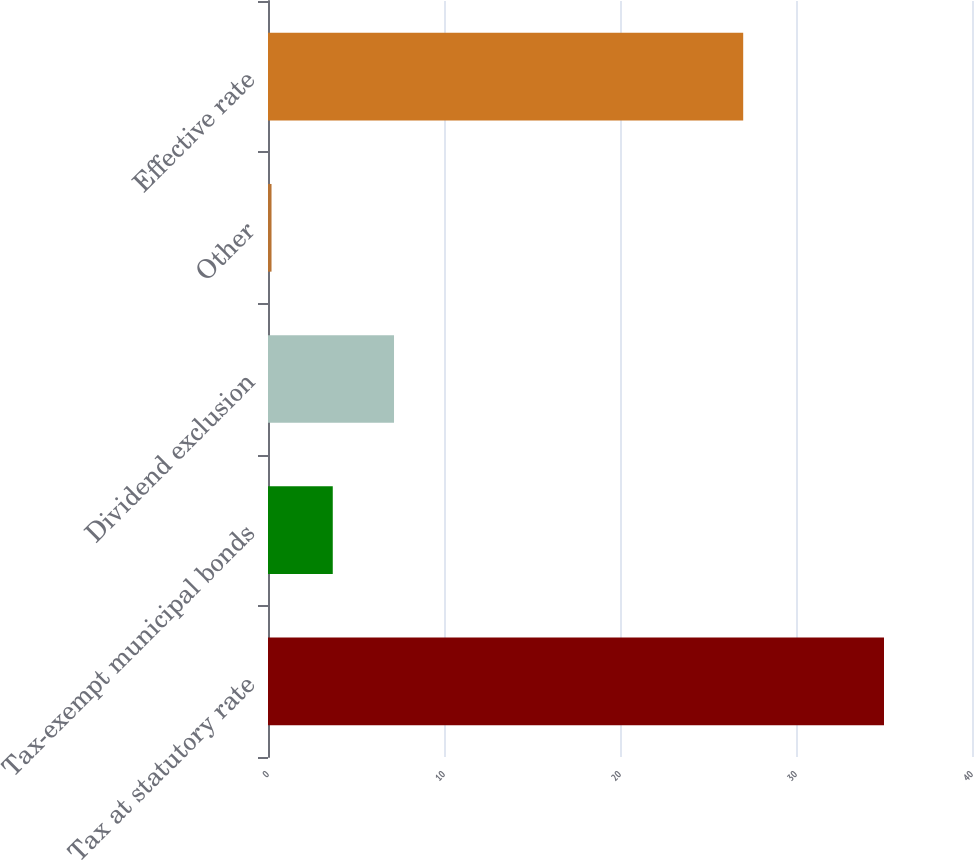<chart> <loc_0><loc_0><loc_500><loc_500><bar_chart><fcel>Tax at statutory rate<fcel>Tax-exempt municipal bonds<fcel>Dividend exclusion<fcel>Other<fcel>Effective rate<nl><fcel>35<fcel>3.68<fcel>7.16<fcel>0.2<fcel>27<nl></chart> 